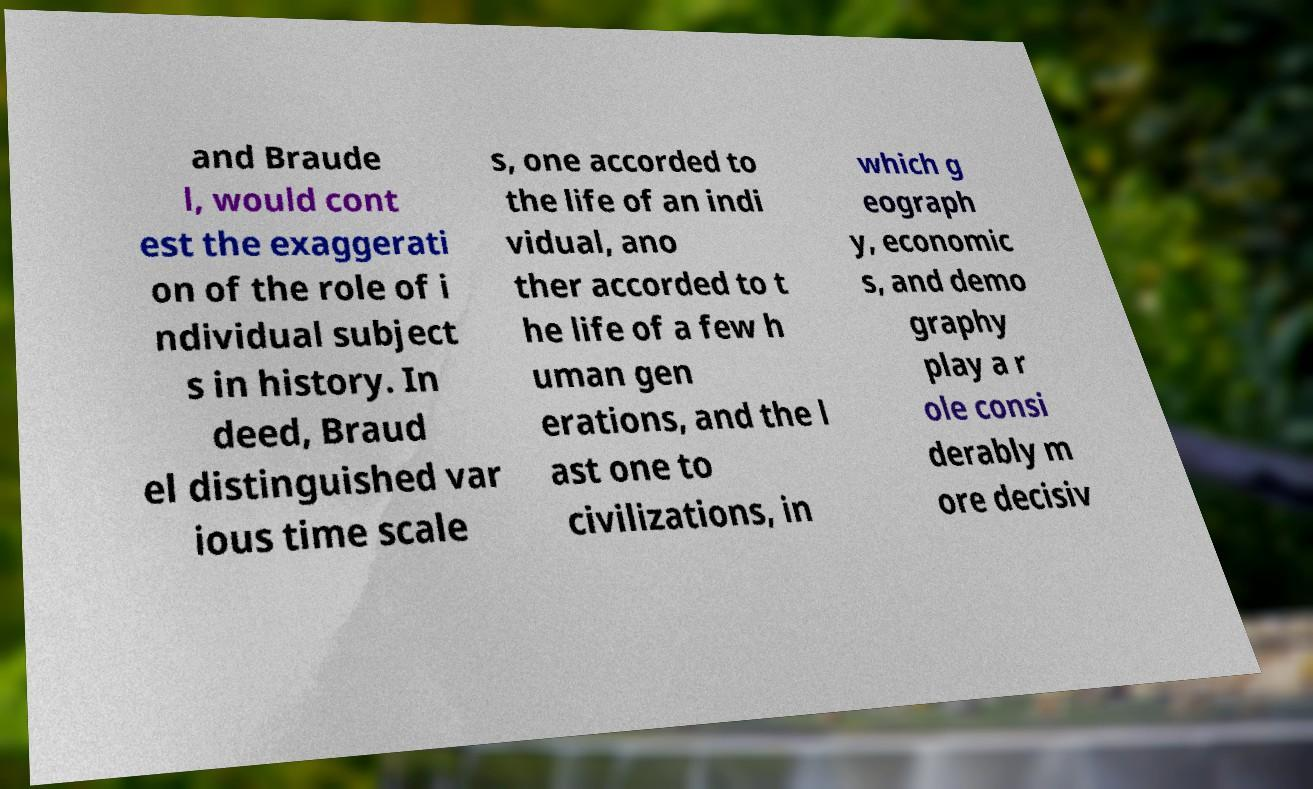Please read and relay the text visible in this image. What does it say? and Braude l, would cont est the exaggerati on of the role of i ndividual subject s in history. In deed, Braud el distinguished var ious time scale s, one accorded to the life of an indi vidual, ano ther accorded to t he life of a few h uman gen erations, and the l ast one to civilizations, in which g eograph y, economic s, and demo graphy play a r ole consi derably m ore decisiv 